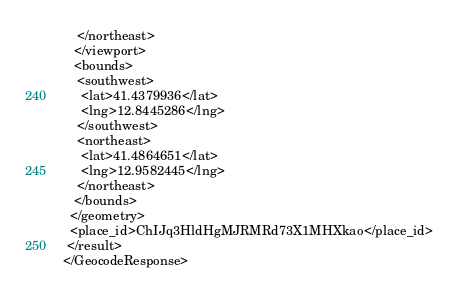Convert code to text. <code><loc_0><loc_0><loc_500><loc_500><_XML_>    </northeast>
   </viewport>
   <bounds>
    <southwest>
     <lat>41.4379936</lat>
     <lng>12.8445286</lng>
    </southwest>
    <northeast>
     <lat>41.4864651</lat>
     <lng>12.9582445</lng>
    </northeast>
   </bounds>
  </geometry>
  <place_id>ChIJq3HldHgMJRMRd73X1MHXkao</place_id>
 </result>
</GeocodeResponse>
</code> 